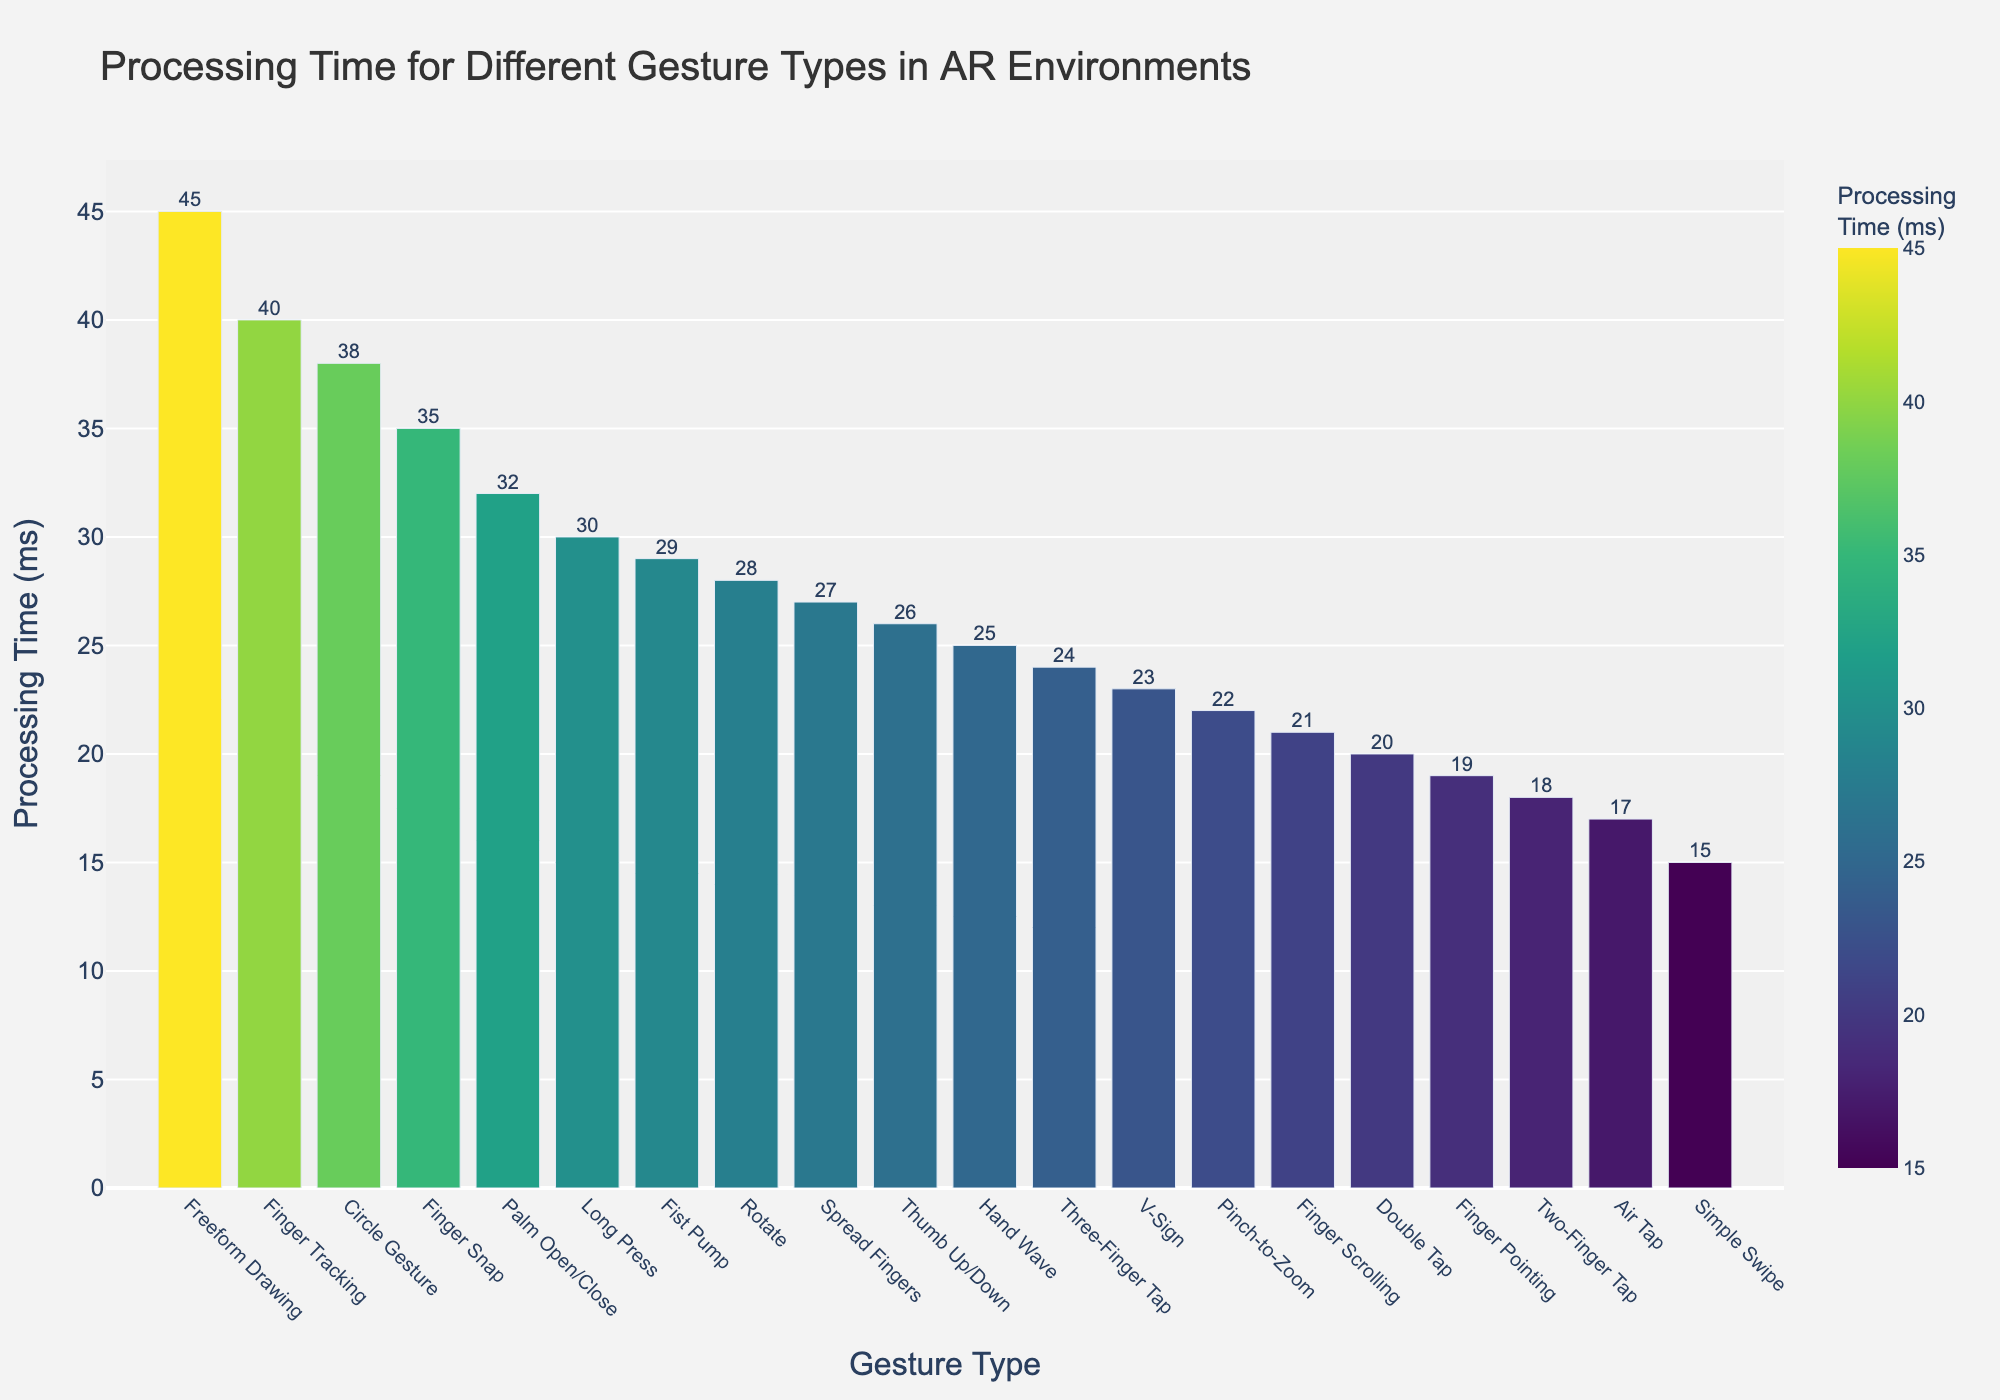What gesture has the highest processing time, and what is its value? By examining the height of the bars, the "Freeform Drawing" has the highest processing time. The label on the top of the bar shows the value as 45 ms.
Answer: Freeform Drawing, 45 ms Which gesture type has a lower processing time, "Pinch-to-Zoom" or "Palm Open/Close"? By comparing the heights of the bars, "Pinch-to-Zoom" has a shorter bar than "Palm Open/Close". The processing times are 22 ms and 32 ms respectively.
Answer: Pinch-to-Zoom What is the processing time difference between "Air Tap" and "Three-Finger Tap"? The processing time for "Air Tap" is 17 ms and for "Three-Finger Tap" is 24 ms. The difference is 24 ms - 17 ms = 7 ms.
Answer: 7 ms Which gesture type falls exactly in the middle when sorted by processing time? Sorting the processing times in ascending order and finding the middle value in the ordered list: "Three-Finger Tap" (24 ms) falls in the middle of 20 gesture types.
Answer: Three-Finger Tap Calculate the average processing time of "Long Press," "Finger Snap," and "Palm Open/Close". The processing times are: "Long Press" = 30 ms, "Finger Snap" = 35 ms, "Palm Open/Close" = 32 ms. The average is (30 + 35 + 32) / 3 = 97 / 3 ≈ 32.3 ms.
Answer: 32.3 ms What is the range of processing times across all gesture types? The range is the difference between the maximum and minimum values. The maximum processing time is 45 ms (Freeform Drawing), and the minimum is 15 ms (Simple Swipe). The range is 45 ms - 15 ms = 30 ms.
Answer: 30 ms Which gestures have a processing time higher than 30 ms? The gestures with processing times higher than 30 ms are "Finger Snap" (35 ms), "Palm Open/Close" (32 ms), "Circle Gesture" (38 ms), "Finger Tracking" (40 ms), and "Freeform Drawing" (45 ms).
Answer: Finger Snap, Palm Open/Close, Circle Gesture, Finger Tracking, Freeform Drawing How does the processing time for "Rotate" compare to the average processing time of all gesture types? First, calculate the sum of all processing times: 15 + 22 + 28 + 18 + 24 + 30 + 20 + 45 + 25 + 35 + 32 + 26 + 19 + 38 + 23 + 29 + 27 + 21 + 17 + 40 = 514 ms. The average is 514 ms / 20 ≈ 25.7 ms. The processing time for "Rotate" is 28 ms, which is slightly above the average of 25.7 ms.
Answer: Above average Identify the gesture with the second-lowest processing time and its value. Sorting the processing times in ascending order, the second-lowest processing time is "Air Tap" (17 ms). Hence, the second-lowest processing time is "Simple Swipe" with 15 ms.
Answer: Air Tap, 17 ms 